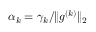Convert formula to latex. <formula><loc_0><loc_0><loc_500><loc_500>\alpha _ { k } = \gamma _ { k } / \| g ^ { ( k ) } \| _ { 2 }</formula> 